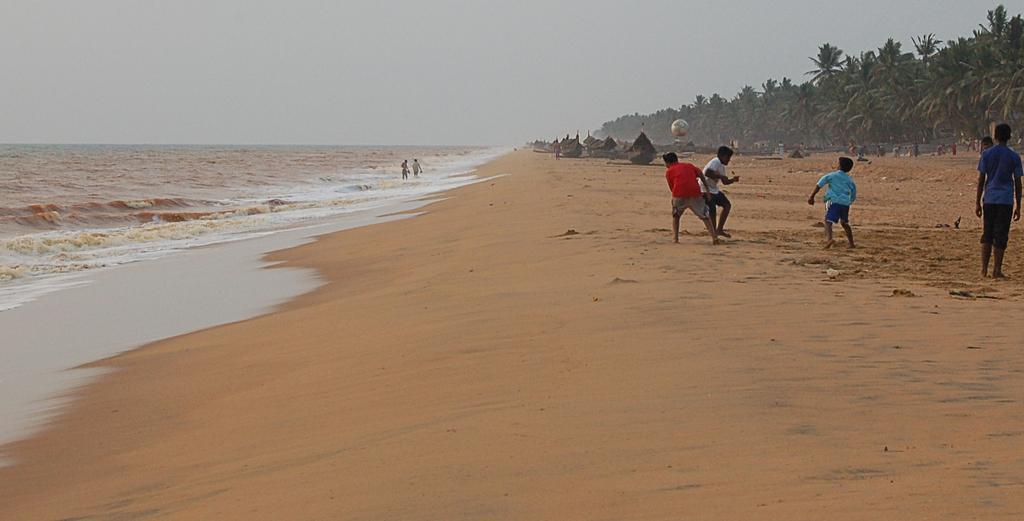Could you give a brief overview of what you see in this image? This picture describes about group of people, few are walking in the water and few are standing, in the background we can see few boats, trees and a ball. 